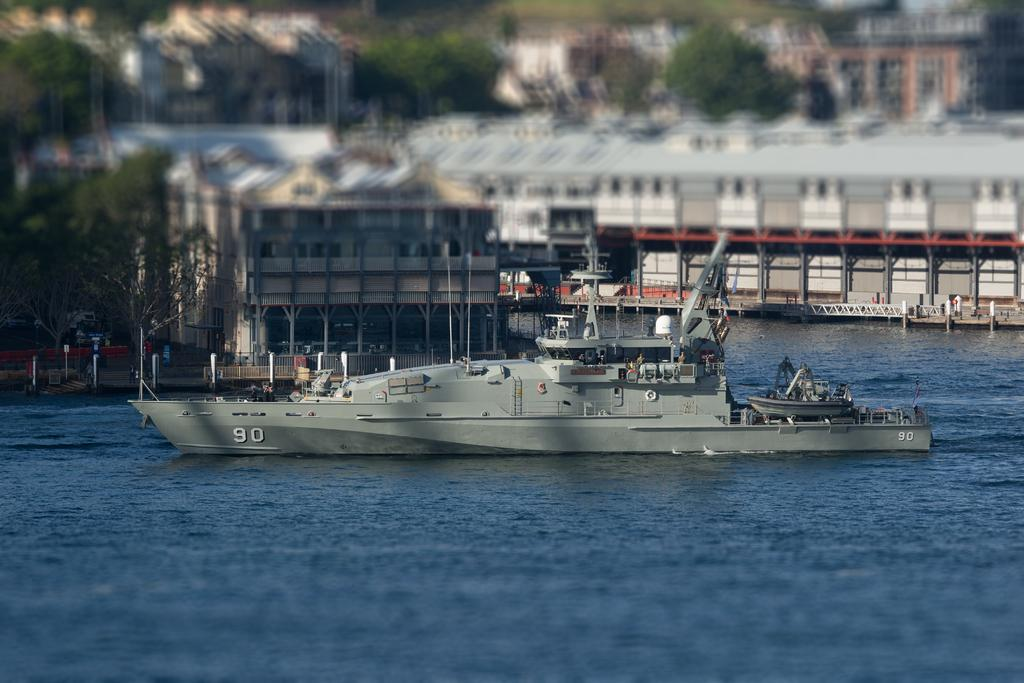What is the main subject of the image? There is a memo in the image. Where is the memo located? The memo is on a river. What can be seen in the background of the image? There are trees and houses in the background of the image. How is the background of the image depicted? The background is blurred. What type of egg is being used as a paperweight for the memo in the image? There is no egg present in the image, and the memo is not depicted as having a paperweight. 